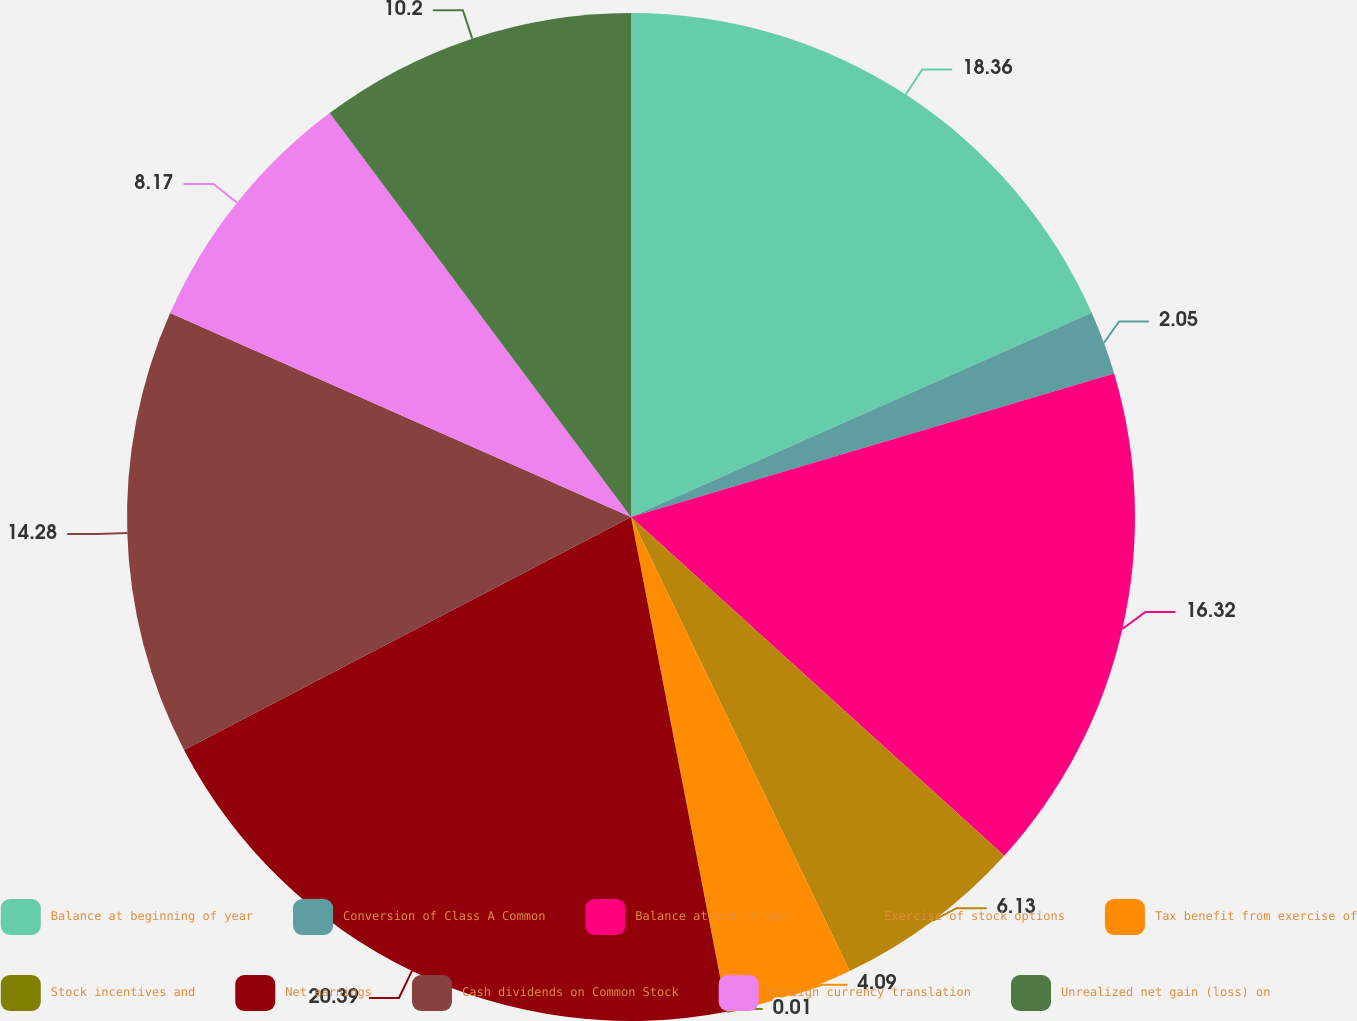Convert chart. <chart><loc_0><loc_0><loc_500><loc_500><pie_chart><fcel>Balance at beginning of year<fcel>Conversion of Class A Common<fcel>Balance at end of year<fcel>Exercise of stock options<fcel>Tax benefit from exercise of<fcel>Stock incentives and<fcel>Net earnings<fcel>Cash dividends on Common Stock<fcel>Foreign currency translation<fcel>Unrealized net gain (loss) on<nl><fcel>18.36%<fcel>2.05%<fcel>16.32%<fcel>6.13%<fcel>4.09%<fcel>0.01%<fcel>20.4%<fcel>14.28%<fcel>8.17%<fcel>10.2%<nl></chart> 